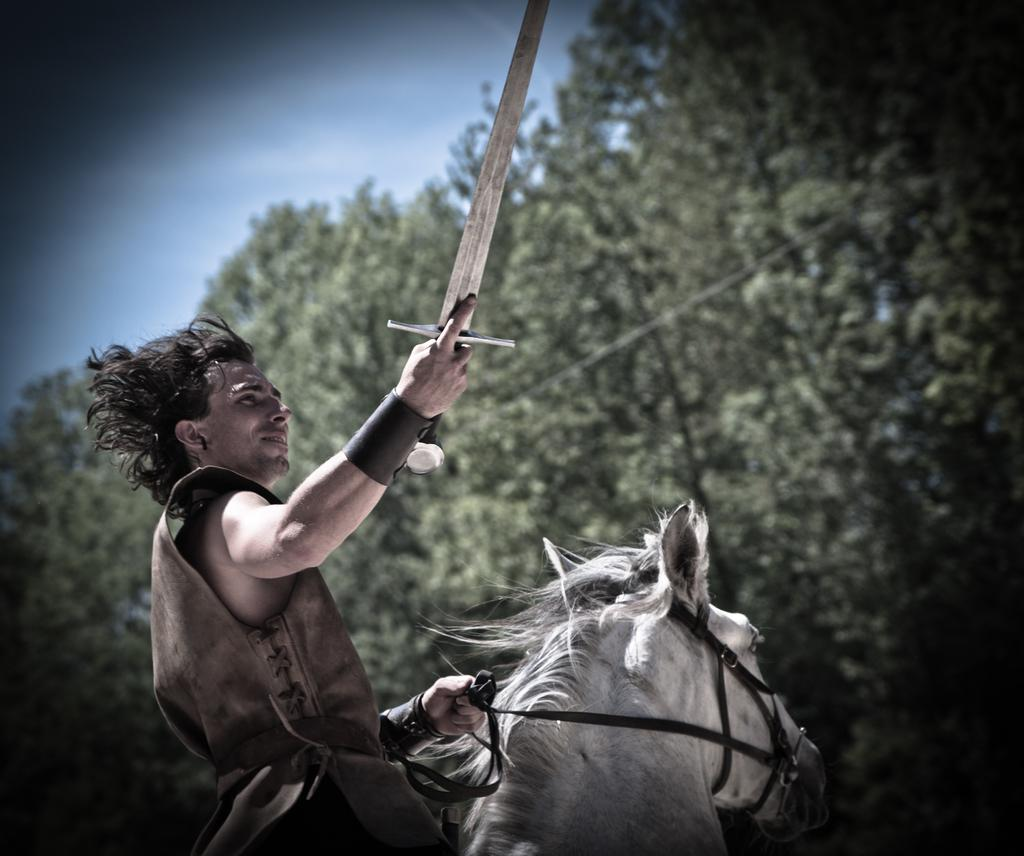What is the main subject of the image? The main subject of the image is a man. What is the man doing in the image? The man is sitting on a horse in the image. What object is the man holding in his hand? The man is holding a knife in his hand. What can be seen in the background of the image? There are trees and the sky visible in the background of the image. What type of insurance policy does the man have for his horse in the image? There is no information about insurance policies in the image, and the man's horse is not the main focus of the image. Can you tell me how many volcanoes are visible in the background of the image? There are no volcanoes visible in the background of the image; only trees and the sky can be seen. 